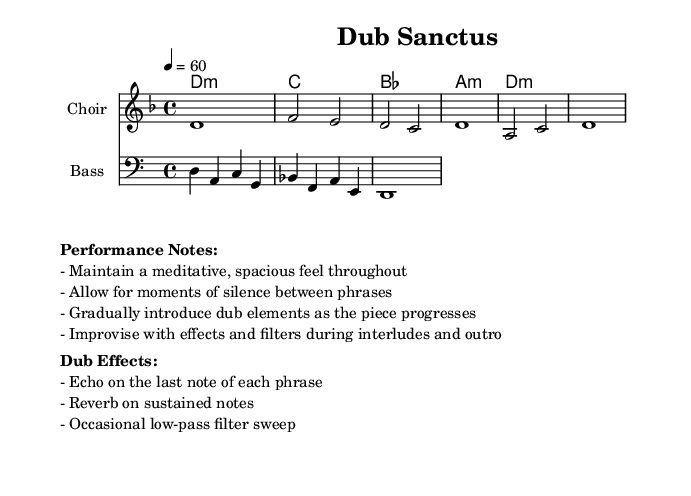What is the key signature of this music? The key signature is D minor, which includes one flat (B flat).
Answer: D minor What is the time signature of the piece? The time signature is 4/4, meaning there are four beats in each measure.
Answer: 4/4 What is the tempo indicated for this piece? The tempo marking is a quarter note equals 60 beats per minute, indicating a slow pace.
Answer: 60 How many measures are there in the melody? There are six measures in the melody as indicated by the vertical lines showing the measure separations.
Answer: 6 What type of effects are suggested for improvisation during interludes? The performance notes suggest improvising with effects and filters, emphasizing the dub-style elements.
Answer: Effects and filters What should be the primary approach to dynamics throughout the piece? The performance notes indicate that a meditative and spacious feel should be maintained, focusing on silence and gradual builds.
Answer: Meditative and spacious feel What is the last chord in the chord progression? The chord progression ends with a D minor chord, which is the same as the key signature.
Answer: D minor 